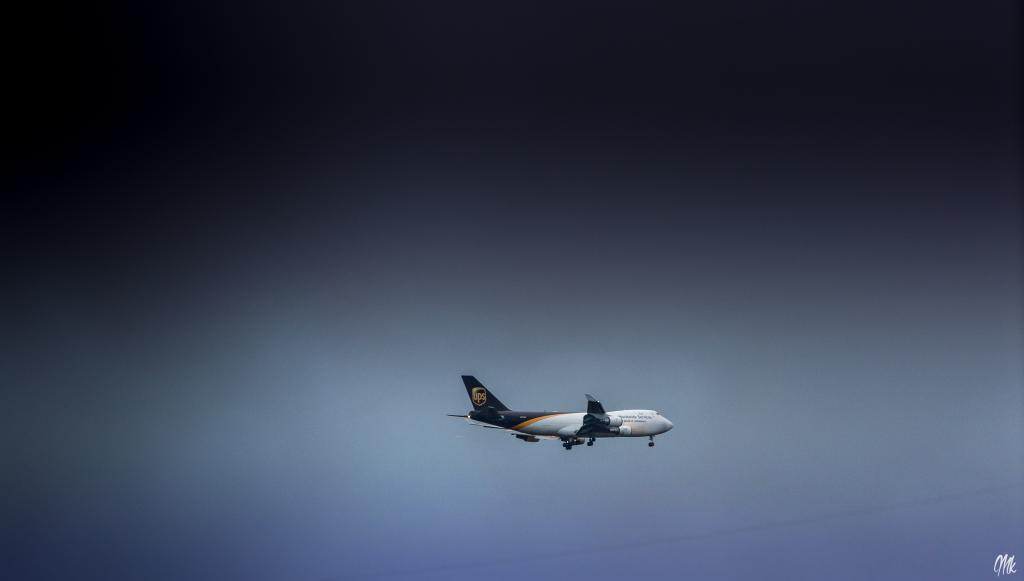What is the main subject of the image? The main subject of the image is an airplane. Where is the airplane located in the image? The airplane is in the air in the image. What can be seen in the background of the image? The sky is visible in the image. What type of curtain can be seen hanging from the airplane in the image? There is no curtain present in the image; it features an airplane in the sky. Can you tell me how many beggars are visible in the image? There are no beggars present in the image; it features an airplane in the sky. 